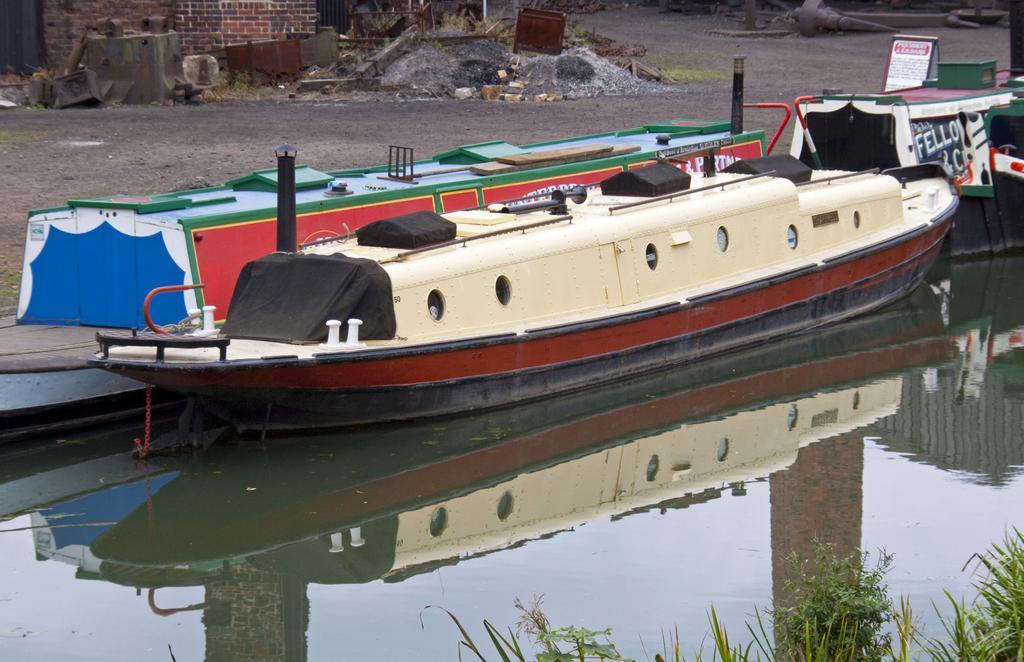In one or two sentences, can you explain what this image depicts? In this image, we can see boats floating on the water. There are plants in the bottom right of the image. There is a wall in the top left of the image. 